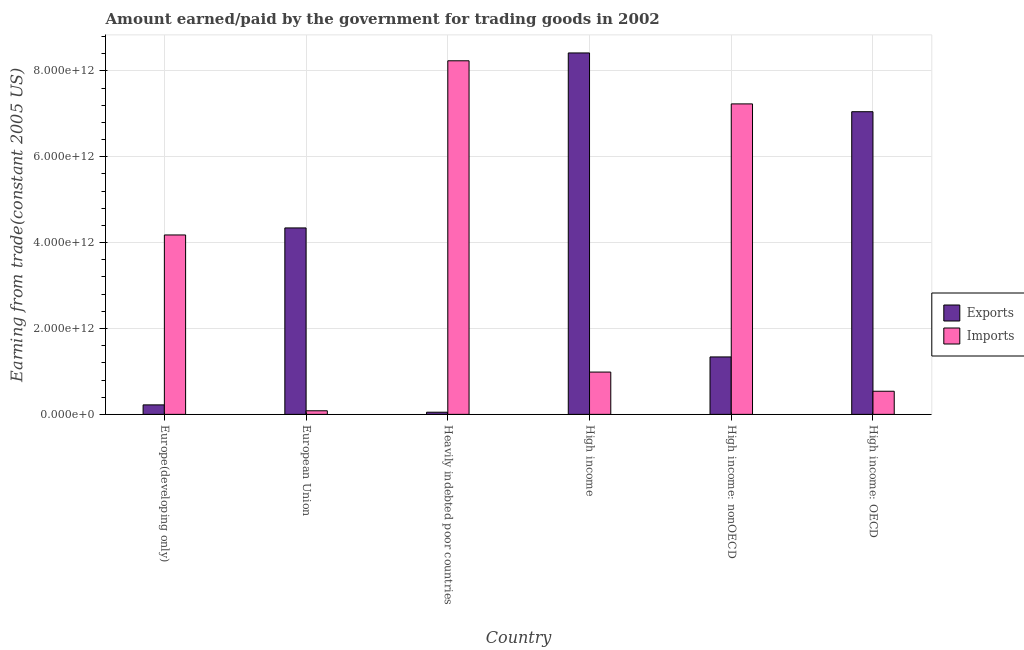Are the number of bars on each tick of the X-axis equal?
Your answer should be very brief. Yes. How many bars are there on the 4th tick from the left?
Offer a terse response. 2. How many bars are there on the 1st tick from the right?
Offer a very short reply. 2. What is the label of the 1st group of bars from the left?
Provide a succinct answer. Europe(developing only). In how many cases, is the number of bars for a given country not equal to the number of legend labels?
Offer a very short reply. 0. What is the amount earned from exports in High income?
Offer a very short reply. 8.42e+12. Across all countries, what is the maximum amount paid for imports?
Offer a very short reply. 8.23e+12. Across all countries, what is the minimum amount paid for imports?
Provide a succinct answer. 8.38e+1. In which country was the amount paid for imports maximum?
Ensure brevity in your answer.  Heavily indebted poor countries. In which country was the amount earned from exports minimum?
Offer a terse response. Heavily indebted poor countries. What is the total amount earned from exports in the graph?
Keep it short and to the point. 2.14e+13. What is the difference between the amount earned from exports in European Union and that in Heavily indebted poor countries?
Your answer should be compact. 4.29e+12. What is the difference between the amount earned from exports in European Union and the amount paid for imports in High income?
Offer a very short reply. 3.36e+12. What is the average amount earned from exports per country?
Provide a succinct answer. 3.57e+12. What is the difference between the amount earned from exports and amount paid for imports in Heavily indebted poor countries?
Offer a terse response. -8.18e+12. In how many countries, is the amount earned from exports greater than 3600000000000 US$?
Your answer should be compact. 3. What is the ratio of the amount paid for imports in Heavily indebted poor countries to that in High income: nonOECD?
Offer a terse response. 1.14. Is the amount earned from exports in Europe(developing only) less than that in High income?
Your response must be concise. Yes. What is the difference between the highest and the second highest amount paid for imports?
Keep it short and to the point. 1.00e+12. What is the difference between the highest and the lowest amount paid for imports?
Your answer should be very brief. 8.15e+12. What does the 1st bar from the left in European Union represents?
Offer a terse response. Exports. What does the 2nd bar from the right in European Union represents?
Keep it short and to the point. Exports. Are all the bars in the graph horizontal?
Provide a short and direct response. No. How many countries are there in the graph?
Provide a short and direct response. 6. What is the difference between two consecutive major ticks on the Y-axis?
Give a very brief answer. 2.00e+12. Are the values on the major ticks of Y-axis written in scientific E-notation?
Your answer should be very brief. Yes. Does the graph contain any zero values?
Ensure brevity in your answer.  No. Where does the legend appear in the graph?
Give a very brief answer. Center right. What is the title of the graph?
Ensure brevity in your answer.  Amount earned/paid by the government for trading goods in 2002. Does "Private creditors" appear as one of the legend labels in the graph?
Offer a terse response. No. What is the label or title of the Y-axis?
Ensure brevity in your answer.  Earning from trade(constant 2005 US). What is the Earning from trade(constant 2005 US) in Exports in Europe(developing only)?
Provide a short and direct response. 2.21e+11. What is the Earning from trade(constant 2005 US) of Imports in Europe(developing only)?
Provide a short and direct response. 4.18e+12. What is the Earning from trade(constant 2005 US) in Exports in European Union?
Keep it short and to the point. 4.34e+12. What is the Earning from trade(constant 2005 US) of Imports in European Union?
Ensure brevity in your answer.  8.38e+1. What is the Earning from trade(constant 2005 US) of Exports in Heavily indebted poor countries?
Ensure brevity in your answer.  5.05e+1. What is the Earning from trade(constant 2005 US) in Imports in Heavily indebted poor countries?
Give a very brief answer. 8.23e+12. What is the Earning from trade(constant 2005 US) in Exports in High income?
Ensure brevity in your answer.  8.42e+12. What is the Earning from trade(constant 2005 US) of Imports in High income?
Offer a terse response. 9.85e+11. What is the Earning from trade(constant 2005 US) in Exports in High income: nonOECD?
Offer a very short reply. 1.34e+12. What is the Earning from trade(constant 2005 US) of Imports in High income: nonOECD?
Provide a short and direct response. 7.23e+12. What is the Earning from trade(constant 2005 US) in Exports in High income: OECD?
Your answer should be compact. 7.05e+12. What is the Earning from trade(constant 2005 US) in Imports in High income: OECD?
Your answer should be very brief. 5.39e+11. Across all countries, what is the maximum Earning from trade(constant 2005 US) in Exports?
Your answer should be very brief. 8.42e+12. Across all countries, what is the maximum Earning from trade(constant 2005 US) of Imports?
Offer a very short reply. 8.23e+12. Across all countries, what is the minimum Earning from trade(constant 2005 US) in Exports?
Provide a succinct answer. 5.05e+1. Across all countries, what is the minimum Earning from trade(constant 2005 US) in Imports?
Your answer should be very brief. 8.38e+1. What is the total Earning from trade(constant 2005 US) in Exports in the graph?
Your answer should be compact. 2.14e+13. What is the total Earning from trade(constant 2005 US) of Imports in the graph?
Ensure brevity in your answer.  2.13e+13. What is the difference between the Earning from trade(constant 2005 US) in Exports in Europe(developing only) and that in European Union?
Ensure brevity in your answer.  -4.12e+12. What is the difference between the Earning from trade(constant 2005 US) in Imports in Europe(developing only) and that in European Union?
Your response must be concise. 4.09e+12. What is the difference between the Earning from trade(constant 2005 US) of Exports in Europe(developing only) and that in Heavily indebted poor countries?
Offer a very short reply. 1.71e+11. What is the difference between the Earning from trade(constant 2005 US) of Imports in Europe(developing only) and that in Heavily indebted poor countries?
Your answer should be compact. -4.06e+12. What is the difference between the Earning from trade(constant 2005 US) in Exports in Europe(developing only) and that in High income?
Your response must be concise. -8.20e+12. What is the difference between the Earning from trade(constant 2005 US) of Imports in Europe(developing only) and that in High income?
Provide a succinct answer. 3.19e+12. What is the difference between the Earning from trade(constant 2005 US) of Exports in Europe(developing only) and that in High income: nonOECD?
Ensure brevity in your answer.  -1.12e+12. What is the difference between the Earning from trade(constant 2005 US) of Imports in Europe(developing only) and that in High income: nonOECD?
Your answer should be very brief. -3.05e+12. What is the difference between the Earning from trade(constant 2005 US) in Exports in Europe(developing only) and that in High income: OECD?
Give a very brief answer. -6.83e+12. What is the difference between the Earning from trade(constant 2005 US) of Imports in Europe(developing only) and that in High income: OECD?
Give a very brief answer. 3.64e+12. What is the difference between the Earning from trade(constant 2005 US) in Exports in European Union and that in Heavily indebted poor countries?
Keep it short and to the point. 4.29e+12. What is the difference between the Earning from trade(constant 2005 US) in Imports in European Union and that in Heavily indebted poor countries?
Offer a very short reply. -8.15e+12. What is the difference between the Earning from trade(constant 2005 US) of Exports in European Union and that in High income?
Provide a short and direct response. -4.08e+12. What is the difference between the Earning from trade(constant 2005 US) of Imports in European Union and that in High income?
Your answer should be compact. -9.01e+11. What is the difference between the Earning from trade(constant 2005 US) of Exports in European Union and that in High income: nonOECD?
Keep it short and to the point. 3.00e+12. What is the difference between the Earning from trade(constant 2005 US) in Imports in European Union and that in High income: nonOECD?
Keep it short and to the point. -7.15e+12. What is the difference between the Earning from trade(constant 2005 US) of Exports in European Union and that in High income: OECD?
Offer a very short reply. -2.71e+12. What is the difference between the Earning from trade(constant 2005 US) of Imports in European Union and that in High income: OECD?
Make the answer very short. -4.55e+11. What is the difference between the Earning from trade(constant 2005 US) of Exports in Heavily indebted poor countries and that in High income?
Your response must be concise. -8.37e+12. What is the difference between the Earning from trade(constant 2005 US) of Imports in Heavily indebted poor countries and that in High income?
Make the answer very short. 7.25e+12. What is the difference between the Earning from trade(constant 2005 US) of Exports in Heavily indebted poor countries and that in High income: nonOECD?
Your answer should be very brief. -1.29e+12. What is the difference between the Earning from trade(constant 2005 US) of Imports in Heavily indebted poor countries and that in High income: nonOECD?
Provide a succinct answer. 1.00e+12. What is the difference between the Earning from trade(constant 2005 US) of Exports in Heavily indebted poor countries and that in High income: OECD?
Your answer should be very brief. -7.00e+12. What is the difference between the Earning from trade(constant 2005 US) of Imports in Heavily indebted poor countries and that in High income: OECD?
Provide a short and direct response. 7.70e+12. What is the difference between the Earning from trade(constant 2005 US) in Exports in High income and that in High income: nonOECD?
Your response must be concise. 7.08e+12. What is the difference between the Earning from trade(constant 2005 US) in Imports in High income and that in High income: nonOECD?
Make the answer very short. -6.25e+12. What is the difference between the Earning from trade(constant 2005 US) in Exports in High income and that in High income: OECD?
Your response must be concise. 1.37e+12. What is the difference between the Earning from trade(constant 2005 US) in Imports in High income and that in High income: OECD?
Give a very brief answer. 4.46e+11. What is the difference between the Earning from trade(constant 2005 US) in Exports in High income: nonOECD and that in High income: OECD?
Give a very brief answer. -5.71e+12. What is the difference between the Earning from trade(constant 2005 US) of Imports in High income: nonOECD and that in High income: OECD?
Offer a very short reply. 6.69e+12. What is the difference between the Earning from trade(constant 2005 US) in Exports in Europe(developing only) and the Earning from trade(constant 2005 US) in Imports in European Union?
Ensure brevity in your answer.  1.37e+11. What is the difference between the Earning from trade(constant 2005 US) of Exports in Europe(developing only) and the Earning from trade(constant 2005 US) of Imports in Heavily indebted poor countries?
Give a very brief answer. -8.01e+12. What is the difference between the Earning from trade(constant 2005 US) of Exports in Europe(developing only) and the Earning from trade(constant 2005 US) of Imports in High income?
Keep it short and to the point. -7.64e+11. What is the difference between the Earning from trade(constant 2005 US) in Exports in Europe(developing only) and the Earning from trade(constant 2005 US) in Imports in High income: nonOECD?
Your answer should be very brief. -7.01e+12. What is the difference between the Earning from trade(constant 2005 US) in Exports in Europe(developing only) and the Earning from trade(constant 2005 US) in Imports in High income: OECD?
Your response must be concise. -3.18e+11. What is the difference between the Earning from trade(constant 2005 US) of Exports in European Union and the Earning from trade(constant 2005 US) of Imports in Heavily indebted poor countries?
Provide a short and direct response. -3.89e+12. What is the difference between the Earning from trade(constant 2005 US) of Exports in European Union and the Earning from trade(constant 2005 US) of Imports in High income?
Offer a terse response. 3.36e+12. What is the difference between the Earning from trade(constant 2005 US) in Exports in European Union and the Earning from trade(constant 2005 US) in Imports in High income: nonOECD?
Offer a very short reply. -2.89e+12. What is the difference between the Earning from trade(constant 2005 US) of Exports in European Union and the Earning from trade(constant 2005 US) of Imports in High income: OECD?
Provide a short and direct response. 3.80e+12. What is the difference between the Earning from trade(constant 2005 US) in Exports in Heavily indebted poor countries and the Earning from trade(constant 2005 US) in Imports in High income?
Keep it short and to the point. -9.35e+11. What is the difference between the Earning from trade(constant 2005 US) of Exports in Heavily indebted poor countries and the Earning from trade(constant 2005 US) of Imports in High income: nonOECD?
Provide a short and direct response. -7.18e+12. What is the difference between the Earning from trade(constant 2005 US) in Exports in Heavily indebted poor countries and the Earning from trade(constant 2005 US) in Imports in High income: OECD?
Ensure brevity in your answer.  -4.88e+11. What is the difference between the Earning from trade(constant 2005 US) in Exports in High income and the Earning from trade(constant 2005 US) in Imports in High income: nonOECD?
Provide a succinct answer. 1.19e+12. What is the difference between the Earning from trade(constant 2005 US) in Exports in High income and the Earning from trade(constant 2005 US) in Imports in High income: OECD?
Keep it short and to the point. 7.88e+12. What is the difference between the Earning from trade(constant 2005 US) in Exports in High income: nonOECD and the Earning from trade(constant 2005 US) in Imports in High income: OECD?
Offer a very short reply. 7.99e+11. What is the average Earning from trade(constant 2005 US) in Exports per country?
Your response must be concise. 3.57e+12. What is the average Earning from trade(constant 2005 US) in Imports per country?
Offer a terse response. 3.54e+12. What is the difference between the Earning from trade(constant 2005 US) of Exports and Earning from trade(constant 2005 US) of Imports in Europe(developing only)?
Make the answer very short. -3.96e+12. What is the difference between the Earning from trade(constant 2005 US) in Exports and Earning from trade(constant 2005 US) in Imports in European Union?
Make the answer very short. 4.26e+12. What is the difference between the Earning from trade(constant 2005 US) of Exports and Earning from trade(constant 2005 US) of Imports in Heavily indebted poor countries?
Make the answer very short. -8.18e+12. What is the difference between the Earning from trade(constant 2005 US) in Exports and Earning from trade(constant 2005 US) in Imports in High income?
Your answer should be very brief. 7.43e+12. What is the difference between the Earning from trade(constant 2005 US) in Exports and Earning from trade(constant 2005 US) in Imports in High income: nonOECD?
Your answer should be compact. -5.89e+12. What is the difference between the Earning from trade(constant 2005 US) in Exports and Earning from trade(constant 2005 US) in Imports in High income: OECD?
Your response must be concise. 6.51e+12. What is the ratio of the Earning from trade(constant 2005 US) in Exports in Europe(developing only) to that in European Union?
Your response must be concise. 0.05. What is the ratio of the Earning from trade(constant 2005 US) of Imports in Europe(developing only) to that in European Union?
Offer a very short reply. 49.84. What is the ratio of the Earning from trade(constant 2005 US) of Exports in Europe(developing only) to that in Heavily indebted poor countries?
Keep it short and to the point. 4.38. What is the ratio of the Earning from trade(constant 2005 US) in Imports in Europe(developing only) to that in Heavily indebted poor countries?
Give a very brief answer. 0.51. What is the ratio of the Earning from trade(constant 2005 US) of Exports in Europe(developing only) to that in High income?
Ensure brevity in your answer.  0.03. What is the ratio of the Earning from trade(constant 2005 US) of Imports in Europe(developing only) to that in High income?
Give a very brief answer. 4.24. What is the ratio of the Earning from trade(constant 2005 US) in Exports in Europe(developing only) to that in High income: nonOECD?
Keep it short and to the point. 0.17. What is the ratio of the Earning from trade(constant 2005 US) in Imports in Europe(developing only) to that in High income: nonOECD?
Your answer should be compact. 0.58. What is the ratio of the Earning from trade(constant 2005 US) in Exports in Europe(developing only) to that in High income: OECD?
Offer a terse response. 0.03. What is the ratio of the Earning from trade(constant 2005 US) in Imports in Europe(developing only) to that in High income: OECD?
Your answer should be very brief. 7.76. What is the ratio of the Earning from trade(constant 2005 US) of Exports in European Union to that in Heavily indebted poor countries?
Offer a terse response. 86. What is the ratio of the Earning from trade(constant 2005 US) in Imports in European Union to that in Heavily indebted poor countries?
Keep it short and to the point. 0.01. What is the ratio of the Earning from trade(constant 2005 US) in Exports in European Union to that in High income?
Make the answer very short. 0.52. What is the ratio of the Earning from trade(constant 2005 US) in Imports in European Union to that in High income?
Provide a short and direct response. 0.09. What is the ratio of the Earning from trade(constant 2005 US) of Exports in European Union to that in High income: nonOECD?
Make the answer very short. 3.25. What is the ratio of the Earning from trade(constant 2005 US) of Imports in European Union to that in High income: nonOECD?
Give a very brief answer. 0.01. What is the ratio of the Earning from trade(constant 2005 US) of Exports in European Union to that in High income: OECD?
Offer a very short reply. 0.62. What is the ratio of the Earning from trade(constant 2005 US) in Imports in European Union to that in High income: OECD?
Offer a terse response. 0.16. What is the ratio of the Earning from trade(constant 2005 US) of Exports in Heavily indebted poor countries to that in High income?
Offer a terse response. 0.01. What is the ratio of the Earning from trade(constant 2005 US) in Imports in Heavily indebted poor countries to that in High income?
Keep it short and to the point. 8.36. What is the ratio of the Earning from trade(constant 2005 US) of Exports in Heavily indebted poor countries to that in High income: nonOECD?
Provide a succinct answer. 0.04. What is the ratio of the Earning from trade(constant 2005 US) in Imports in Heavily indebted poor countries to that in High income: nonOECD?
Ensure brevity in your answer.  1.14. What is the ratio of the Earning from trade(constant 2005 US) in Exports in Heavily indebted poor countries to that in High income: OECD?
Your answer should be compact. 0.01. What is the ratio of the Earning from trade(constant 2005 US) in Imports in Heavily indebted poor countries to that in High income: OECD?
Provide a succinct answer. 15.28. What is the ratio of the Earning from trade(constant 2005 US) of Exports in High income to that in High income: nonOECD?
Provide a short and direct response. 6.29. What is the ratio of the Earning from trade(constant 2005 US) in Imports in High income to that in High income: nonOECD?
Offer a very short reply. 0.14. What is the ratio of the Earning from trade(constant 2005 US) of Exports in High income to that in High income: OECD?
Ensure brevity in your answer.  1.19. What is the ratio of the Earning from trade(constant 2005 US) in Imports in High income to that in High income: OECD?
Your answer should be very brief. 1.83. What is the ratio of the Earning from trade(constant 2005 US) in Exports in High income: nonOECD to that in High income: OECD?
Make the answer very short. 0.19. What is the ratio of the Earning from trade(constant 2005 US) of Imports in High income: nonOECD to that in High income: OECD?
Make the answer very short. 13.42. What is the difference between the highest and the second highest Earning from trade(constant 2005 US) in Exports?
Provide a short and direct response. 1.37e+12. What is the difference between the highest and the second highest Earning from trade(constant 2005 US) in Imports?
Give a very brief answer. 1.00e+12. What is the difference between the highest and the lowest Earning from trade(constant 2005 US) in Exports?
Give a very brief answer. 8.37e+12. What is the difference between the highest and the lowest Earning from trade(constant 2005 US) in Imports?
Your answer should be compact. 8.15e+12. 